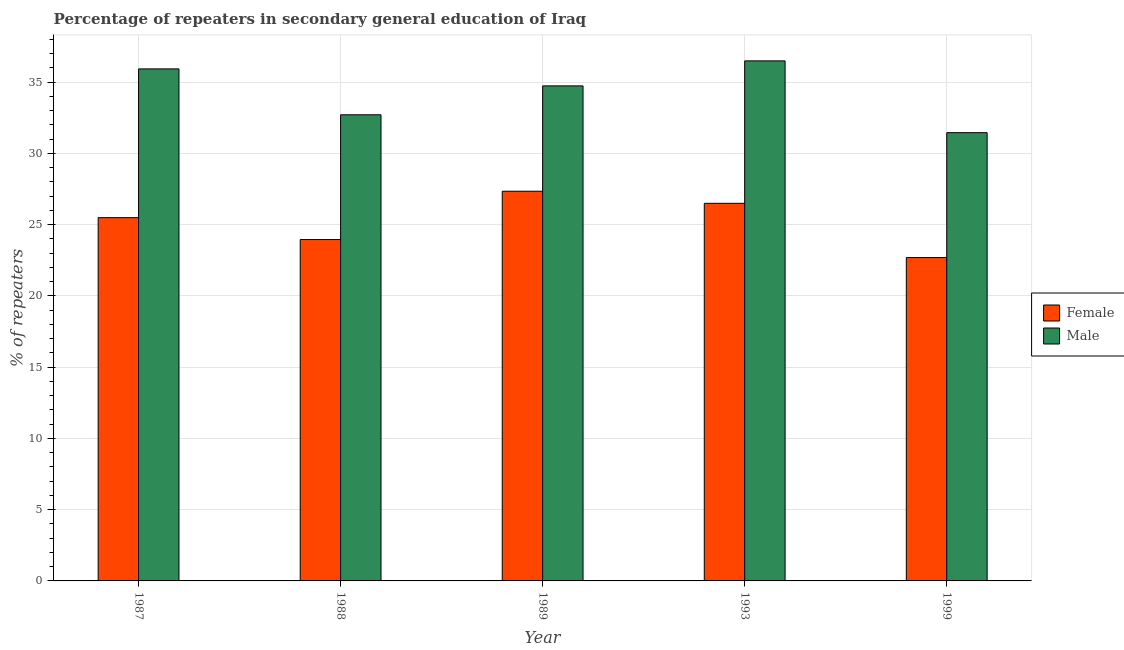How many different coloured bars are there?
Your answer should be compact. 2. How many groups of bars are there?
Provide a short and direct response. 5. Are the number of bars per tick equal to the number of legend labels?
Your response must be concise. Yes. How many bars are there on the 4th tick from the left?
Your response must be concise. 2. What is the percentage of male repeaters in 1987?
Your answer should be very brief. 35.93. Across all years, what is the maximum percentage of female repeaters?
Provide a succinct answer. 27.34. Across all years, what is the minimum percentage of female repeaters?
Give a very brief answer. 22.69. In which year was the percentage of female repeaters maximum?
Your response must be concise. 1989. What is the total percentage of male repeaters in the graph?
Provide a succinct answer. 171.32. What is the difference between the percentage of female repeaters in 1989 and that in 1993?
Your answer should be very brief. 0.85. What is the difference between the percentage of male repeaters in 1988 and the percentage of female repeaters in 1987?
Make the answer very short. -3.22. What is the average percentage of male repeaters per year?
Provide a short and direct response. 34.26. In the year 1989, what is the difference between the percentage of male repeaters and percentage of female repeaters?
Provide a succinct answer. 0. What is the ratio of the percentage of male repeaters in 1988 to that in 1999?
Make the answer very short. 1.04. Is the percentage of female repeaters in 1988 less than that in 1993?
Ensure brevity in your answer.  Yes. What is the difference between the highest and the second highest percentage of female repeaters?
Your answer should be compact. 0.85. What is the difference between the highest and the lowest percentage of male repeaters?
Offer a very short reply. 5.04. In how many years, is the percentage of male repeaters greater than the average percentage of male repeaters taken over all years?
Keep it short and to the point. 3. What does the 1st bar from the left in 1987 represents?
Provide a succinct answer. Female. What does the 1st bar from the right in 1987 represents?
Provide a short and direct response. Male. What is the difference between two consecutive major ticks on the Y-axis?
Your answer should be very brief. 5. Are the values on the major ticks of Y-axis written in scientific E-notation?
Your answer should be compact. No. Does the graph contain grids?
Your answer should be very brief. Yes. Where does the legend appear in the graph?
Offer a terse response. Center right. What is the title of the graph?
Give a very brief answer. Percentage of repeaters in secondary general education of Iraq. What is the label or title of the Y-axis?
Your answer should be very brief. % of repeaters. What is the % of repeaters in Female in 1987?
Give a very brief answer. 25.49. What is the % of repeaters in Male in 1987?
Provide a succinct answer. 35.93. What is the % of repeaters of Female in 1988?
Your response must be concise. 23.95. What is the % of repeaters of Male in 1988?
Provide a succinct answer. 32.71. What is the % of repeaters of Female in 1989?
Your response must be concise. 27.34. What is the % of repeaters of Male in 1989?
Give a very brief answer. 34.74. What is the % of repeaters of Female in 1993?
Offer a very short reply. 26.5. What is the % of repeaters in Male in 1993?
Offer a terse response. 36.49. What is the % of repeaters in Female in 1999?
Give a very brief answer. 22.69. What is the % of repeaters in Male in 1999?
Keep it short and to the point. 31.46. Across all years, what is the maximum % of repeaters of Female?
Your response must be concise. 27.34. Across all years, what is the maximum % of repeaters of Male?
Offer a very short reply. 36.49. Across all years, what is the minimum % of repeaters in Female?
Ensure brevity in your answer.  22.69. Across all years, what is the minimum % of repeaters in Male?
Offer a terse response. 31.46. What is the total % of repeaters in Female in the graph?
Keep it short and to the point. 125.98. What is the total % of repeaters in Male in the graph?
Make the answer very short. 171.32. What is the difference between the % of repeaters in Female in 1987 and that in 1988?
Your answer should be compact. 1.54. What is the difference between the % of repeaters of Male in 1987 and that in 1988?
Ensure brevity in your answer.  3.22. What is the difference between the % of repeaters in Female in 1987 and that in 1989?
Your answer should be very brief. -1.85. What is the difference between the % of repeaters in Male in 1987 and that in 1989?
Offer a terse response. 1.19. What is the difference between the % of repeaters in Female in 1987 and that in 1993?
Your response must be concise. -1. What is the difference between the % of repeaters of Male in 1987 and that in 1993?
Ensure brevity in your answer.  -0.56. What is the difference between the % of repeaters in Female in 1987 and that in 1999?
Provide a short and direct response. 2.8. What is the difference between the % of repeaters of Male in 1987 and that in 1999?
Your answer should be very brief. 4.47. What is the difference between the % of repeaters in Female in 1988 and that in 1989?
Give a very brief answer. -3.39. What is the difference between the % of repeaters of Male in 1988 and that in 1989?
Your answer should be very brief. -2.03. What is the difference between the % of repeaters of Female in 1988 and that in 1993?
Provide a succinct answer. -2.54. What is the difference between the % of repeaters in Male in 1988 and that in 1993?
Your answer should be compact. -3.78. What is the difference between the % of repeaters of Female in 1988 and that in 1999?
Provide a succinct answer. 1.26. What is the difference between the % of repeaters in Male in 1988 and that in 1999?
Make the answer very short. 1.25. What is the difference between the % of repeaters in Female in 1989 and that in 1993?
Keep it short and to the point. 0.85. What is the difference between the % of repeaters in Male in 1989 and that in 1993?
Your answer should be compact. -1.76. What is the difference between the % of repeaters of Female in 1989 and that in 1999?
Make the answer very short. 4.65. What is the difference between the % of repeaters of Male in 1989 and that in 1999?
Make the answer very short. 3.28. What is the difference between the % of repeaters in Female in 1993 and that in 1999?
Your answer should be compact. 3.81. What is the difference between the % of repeaters of Male in 1993 and that in 1999?
Provide a short and direct response. 5.04. What is the difference between the % of repeaters of Female in 1987 and the % of repeaters of Male in 1988?
Offer a very short reply. -7.22. What is the difference between the % of repeaters of Female in 1987 and the % of repeaters of Male in 1989?
Your answer should be compact. -9.24. What is the difference between the % of repeaters of Female in 1987 and the % of repeaters of Male in 1993?
Your answer should be very brief. -11. What is the difference between the % of repeaters of Female in 1987 and the % of repeaters of Male in 1999?
Offer a very short reply. -5.96. What is the difference between the % of repeaters in Female in 1988 and the % of repeaters in Male in 1989?
Make the answer very short. -10.78. What is the difference between the % of repeaters in Female in 1988 and the % of repeaters in Male in 1993?
Provide a short and direct response. -12.54. What is the difference between the % of repeaters of Female in 1988 and the % of repeaters of Male in 1999?
Provide a short and direct response. -7.5. What is the difference between the % of repeaters in Female in 1989 and the % of repeaters in Male in 1993?
Provide a short and direct response. -9.15. What is the difference between the % of repeaters of Female in 1989 and the % of repeaters of Male in 1999?
Provide a succinct answer. -4.11. What is the difference between the % of repeaters in Female in 1993 and the % of repeaters in Male in 1999?
Ensure brevity in your answer.  -4.96. What is the average % of repeaters in Female per year?
Your answer should be very brief. 25.2. What is the average % of repeaters of Male per year?
Make the answer very short. 34.26. In the year 1987, what is the difference between the % of repeaters in Female and % of repeaters in Male?
Ensure brevity in your answer.  -10.44. In the year 1988, what is the difference between the % of repeaters of Female and % of repeaters of Male?
Make the answer very short. -8.75. In the year 1989, what is the difference between the % of repeaters in Female and % of repeaters in Male?
Ensure brevity in your answer.  -7.39. In the year 1993, what is the difference between the % of repeaters of Female and % of repeaters of Male?
Your answer should be very brief. -10. In the year 1999, what is the difference between the % of repeaters in Female and % of repeaters in Male?
Your response must be concise. -8.76. What is the ratio of the % of repeaters of Female in 1987 to that in 1988?
Provide a succinct answer. 1.06. What is the ratio of the % of repeaters in Male in 1987 to that in 1988?
Keep it short and to the point. 1.1. What is the ratio of the % of repeaters in Female in 1987 to that in 1989?
Your response must be concise. 0.93. What is the ratio of the % of repeaters in Male in 1987 to that in 1989?
Make the answer very short. 1.03. What is the ratio of the % of repeaters of Female in 1987 to that in 1993?
Keep it short and to the point. 0.96. What is the ratio of the % of repeaters of Male in 1987 to that in 1993?
Your answer should be compact. 0.98. What is the ratio of the % of repeaters in Female in 1987 to that in 1999?
Keep it short and to the point. 1.12. What is the ratio of the % of repeaters of Male in 1987 to that in 1999?
Offer a very short reply. 1.14. What is the ratio of the % of repeaters of Female in 1988 to that in 1989?
Offer a terse response. 0.88. What is the ratio of the % of repeaters in Male in 1988 to that in 1989?
Provide a short and direct response. 0.94. What is the ratio of the % of repeaters of Female in 1988 to that in 1993?
Give a very brief answer. 0.9. What is the ratio of the % of repeaters in Male in 1988 to that in 1993?
Your response must be concise. 0.9. What is the ratio of the % of repeaters of Female in 1988 to that in 1999?
Make the answer very short. 1.06. What is the ratio of the % of repeaters in Male in 1988 to that in 1999?
Your response must be concise. 1.04. What is the ratio of the % of repeaters of Female in 1989 to that in 1993?
Give a very brief answer. 1.03. What is the ratio of the % of repeaters in Male in 1989 to that in 1993?
Make the answer very short. 0.95. What is the ratio of the % of repeaters of Female in 1989 to that in 1999?
Provide a short and direct response. 1.21. What is the ratio of the % of repeaters of Male in 1989 to that in 1999?
Give a very brief answer. 1.1. What is the ratio of the % of repeaters in Female in 1993 to that in 1999?
Give a very brief answer. 1.17. What is the ratio of the % of repeaters in Male in 1993 to that in 1999?
Offer a terse response. 1.16. What is the difference between the highest and the second highest % of repeaters in Female?
Provide a succinct answer. 0.85. What is the difference between the highest and the second highest % of repeaters of Male?
Give a very brief answer. 0.56. What is the difference between the highest and the lowest % of repeaters of Female?
Your response must be concise. 4.65. What is the difference between the highest and the lowest % of repeaters in Male?
Offer a very short reply. 5.04. 